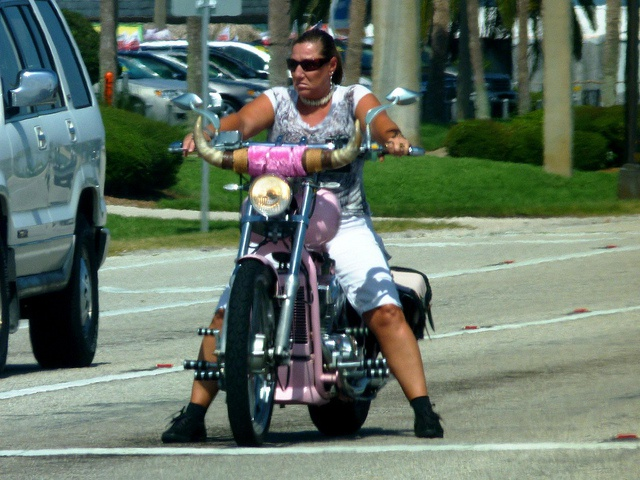Describe the objects in this image and their specific colors. I can see motorcycle in blue, black, gray, and darkgray tones, car in blue, black, teal, and gray tones, people in blue, black, white, and gray tones, car in blue, teal, gray, and black tones, and car in blue, black, gray, and teal tones in this image. 